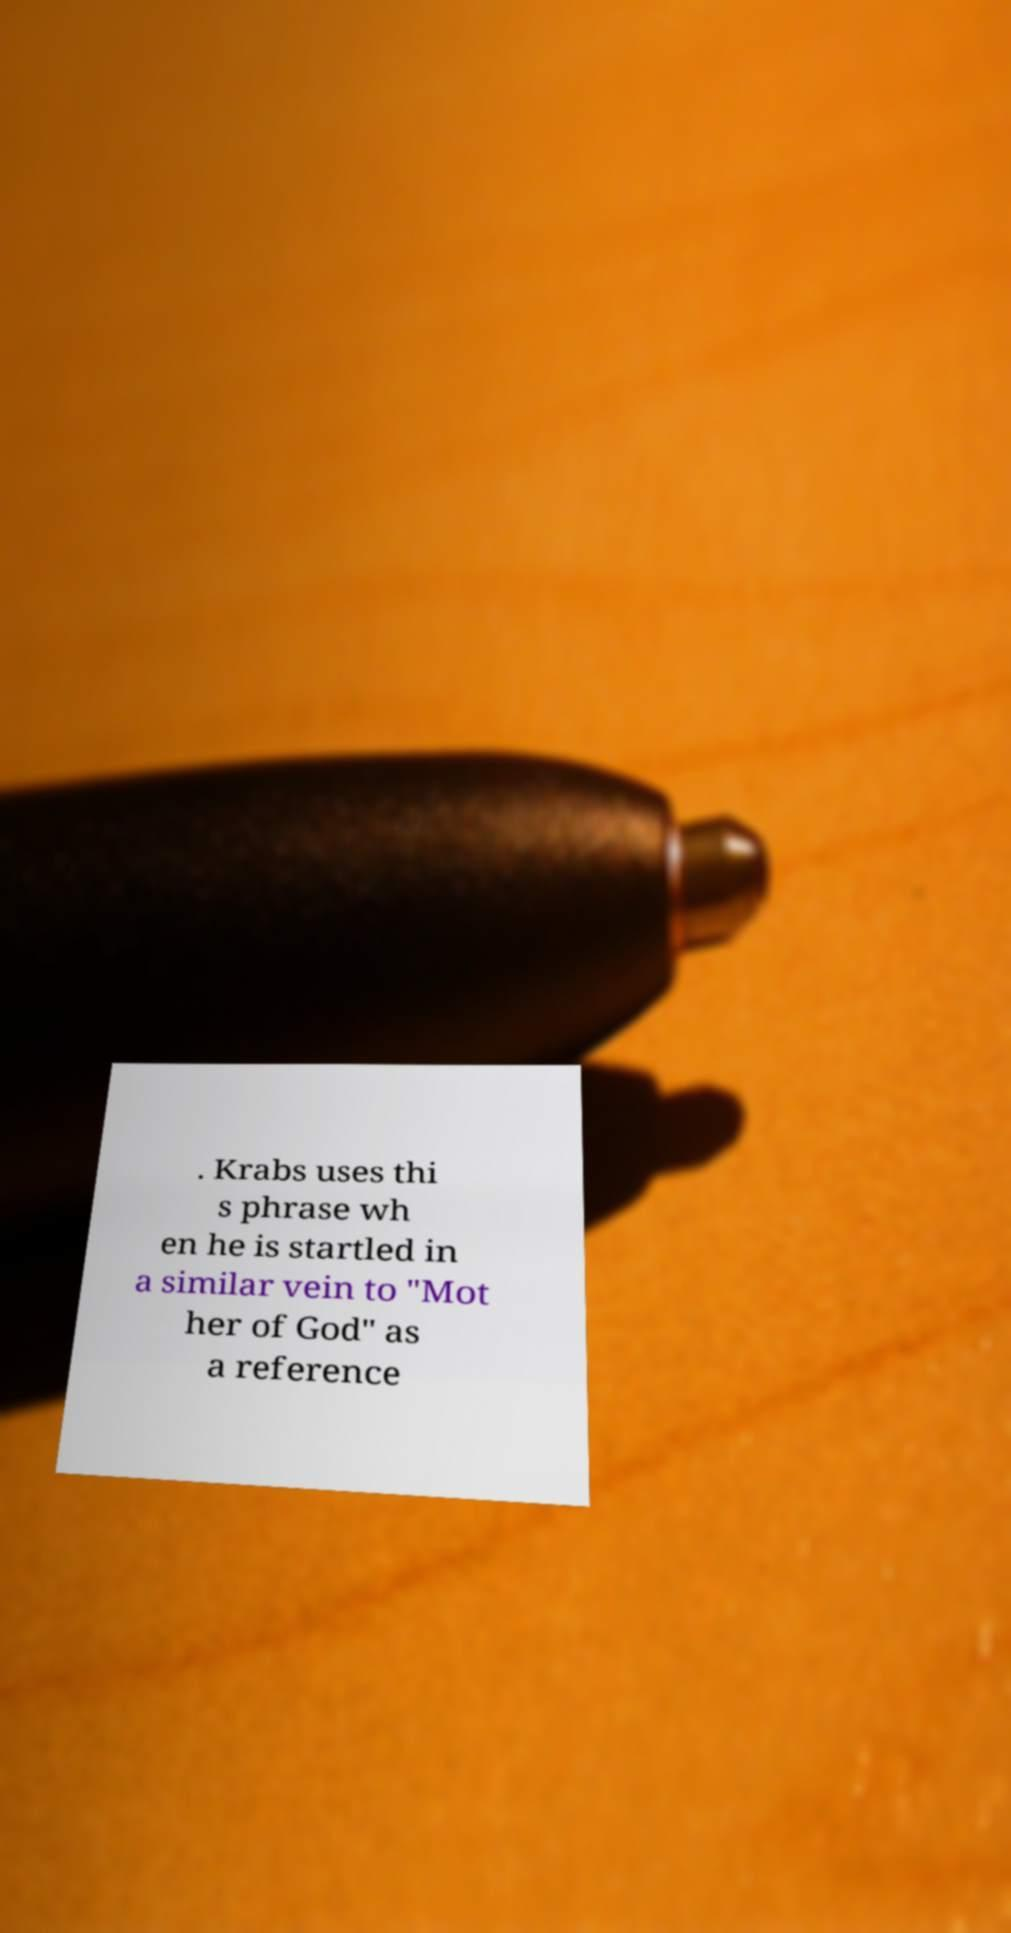Please read and relay the text visible in this image. What does it say? . Krabs uses thi s phrase wh en he is startled in a similar vein to "Mot her of God" as a reference 